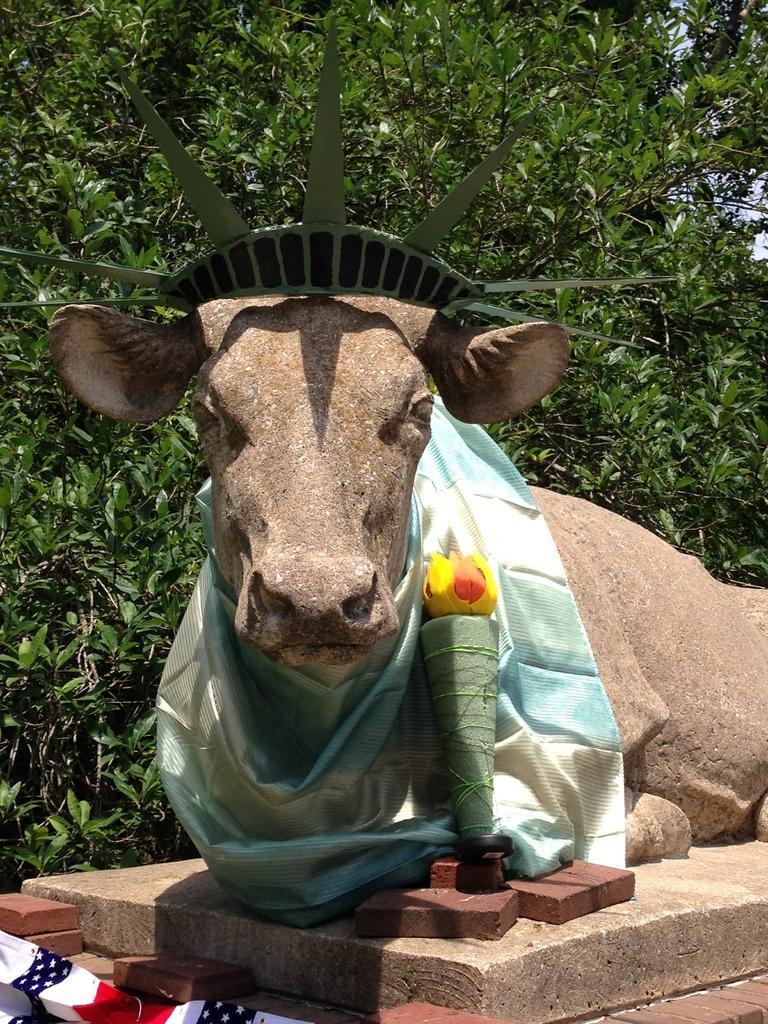Can you describe this image briefly? To this statue there is a cloth and objects. Background we can see green leaves. 